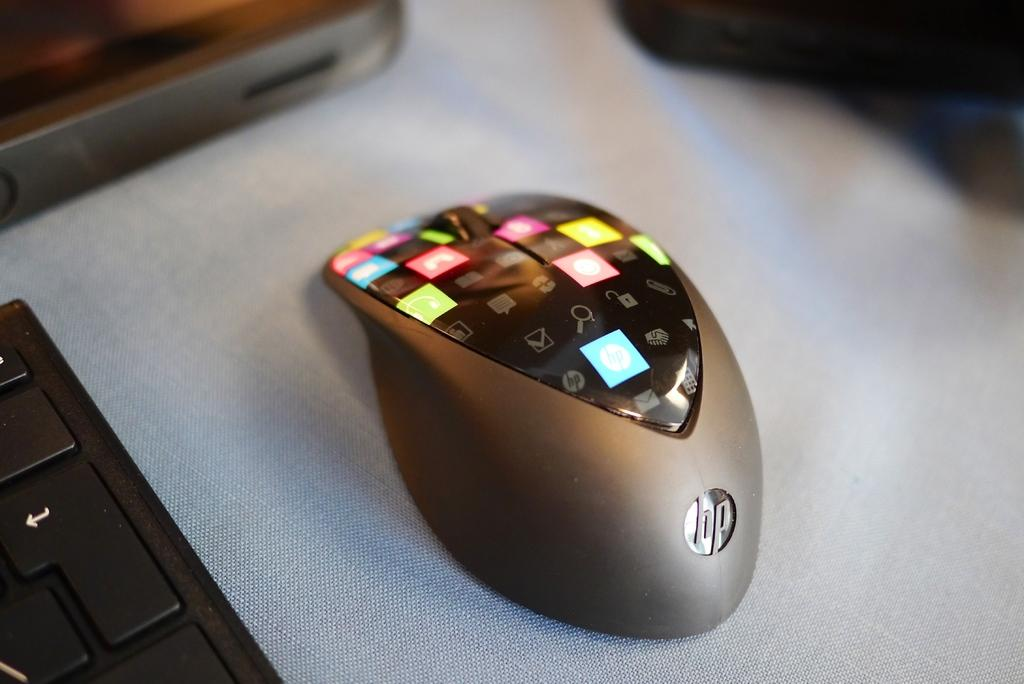<image>
Render a clear and concise summary of the photo. A HP smart mouse with several lit up touch capacitive buttons. 